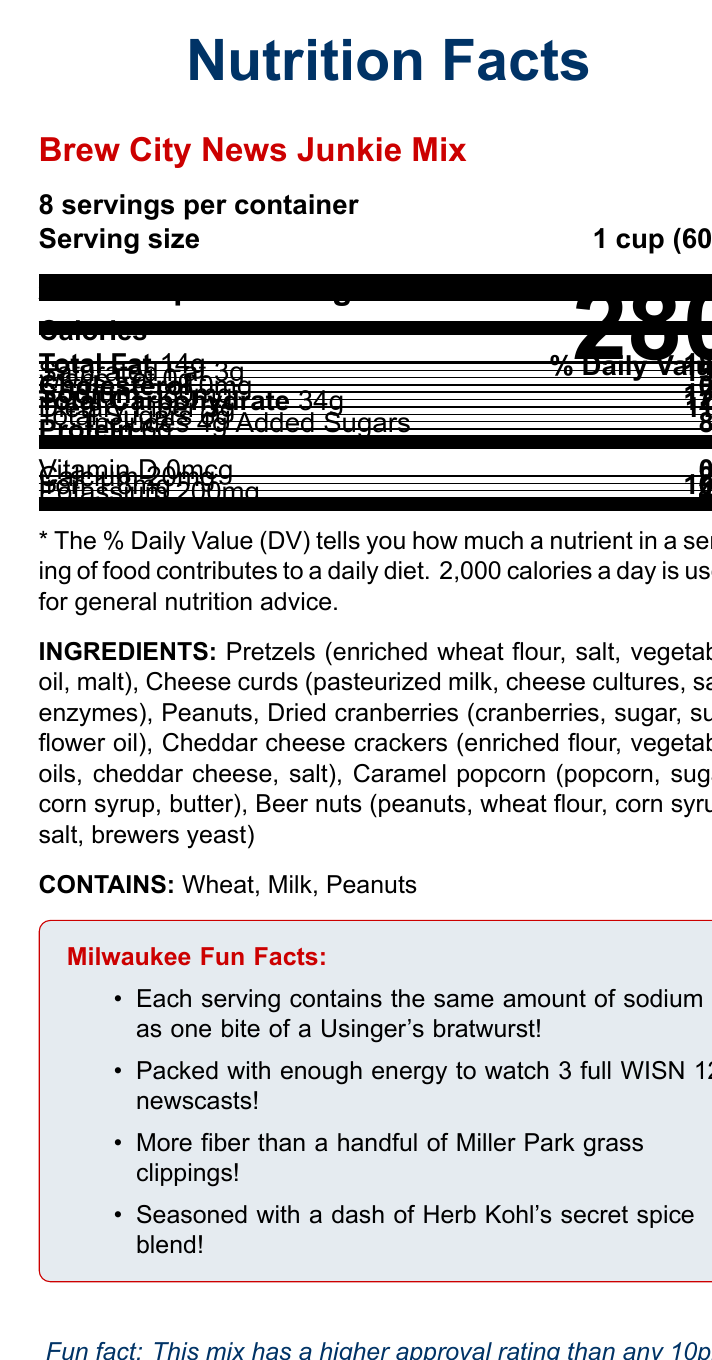what is the product name? The product name is listed at the top of the nutrition facts label as "Brew City News Junkie Mix."
Answer: Brew City News Junkie Mix how many servings are there per container? The document states that there are 8 servings per container, located near the top of the label.
Answer: 8 how many calories are in a serving? The number of calories per serving is prominently displayed as 280 in large font.
Answer: 280 what is the serving size in grams? The serving size is specified as "1 cup (60g)" on the label.
Answer: 60g what are the total carbohydrates per serving? The document lists the "Total Carbohydrate" amount per serving as 34g.
Answer: 34g what percentage of the daily value is the sodium content per serving? The sodium content per serving is 380mg, which is 17% of the daily value.
Answer: 17% name three ingredients in this snack mix The ingredients listed include "Pretzels (enriched wheat flour, salt, vegetable oil, malt), Cheese curds (pasteurized milk, cheese cultures, salt, enzymes), Peanuts."
Answer: Pretzels, Cheese curds, Peanuts does the Brew City News Junkie Mix contain anything for people with peanut allergies to be concerned about? The allergy information specifically states "Contains: Wheat, Milk, Peanuts."
Answer: Yes how many grams of protein does a serving contain? The protein content per serving is listed as 6g in the nutrition facts.
Answer: 6g which fun fact relates the energy of the snack mix to local news broadcasts? 1. Contains the same sodium as a Usinger's bratwurst 2. Enough energy to watch 3 WISN 12 newscasts 3. More fiber than Miller Park grass clippings 4. Seasoned with Herb Kohl's secret spice blend One of the Milwaukee Fun Facts states, "Packed with enough energy to watch 3 full WISN 12 newscasts!"
Answer: 2. Enough energy to watch 3 WISN 12 newscasts what is the approval rating of this mix compared to any 10pm newscast in Milwaukee history? A. Higher  B. Lower C. About the same D. Cannot be determined The document states, "Fun fact: This mix has a higher approval rating than any 10pm newscast in Milwaukee history!"
Answer: A. Higher does the label provide the amount of Vitamin C per serving? The document does not list any information regarding the amount of Vitamin C per serving.
Answer: No summarize the main points of the Brew City News Junkie Mix nutrition facts label. The explanation summarizes all key nutritional information, ingredients, allergy warnings, and Milwaukee fun facts presented in the document.
Answer: The Brew City News Junkie Mix contains 280 calories per 1 cup (60g) serving, with 8 servings per container. It has 14g of total fat, 3g of saturated fat, no trans fat, no cholesterol, and 380mg of sodium. The mix also includes 34g of total carbohydrates with 3g of dietary fiber and 6g of total sugars, including 4g of added sugars. It provides 6g of protein and small amounts of calcium and iron. The ingredients are pretzels, cheese curds, peanuts, dried cranberries, cheddar cheese crackers, caramel popcorn, and beer nuts. The label also provides Milwaukee-themed fun facts and states that the mix contains wheat, milk, and peanuts. how much saturated fat is in a serving? The document states that each serving contains 3g of saturated fat.
Answer: 3g what percentage of the daily value of iron does a serving provide? The document details that each serving provides 1.8mg of iron, which is 10% of the daily value.
Answer: 10% which ingredient might be responsible for the caramel flavor in the mix? The ingredients list includes "Caramel popcorn," which indicates the source of the caramel flavor.
Answer: Caramel popcorn 